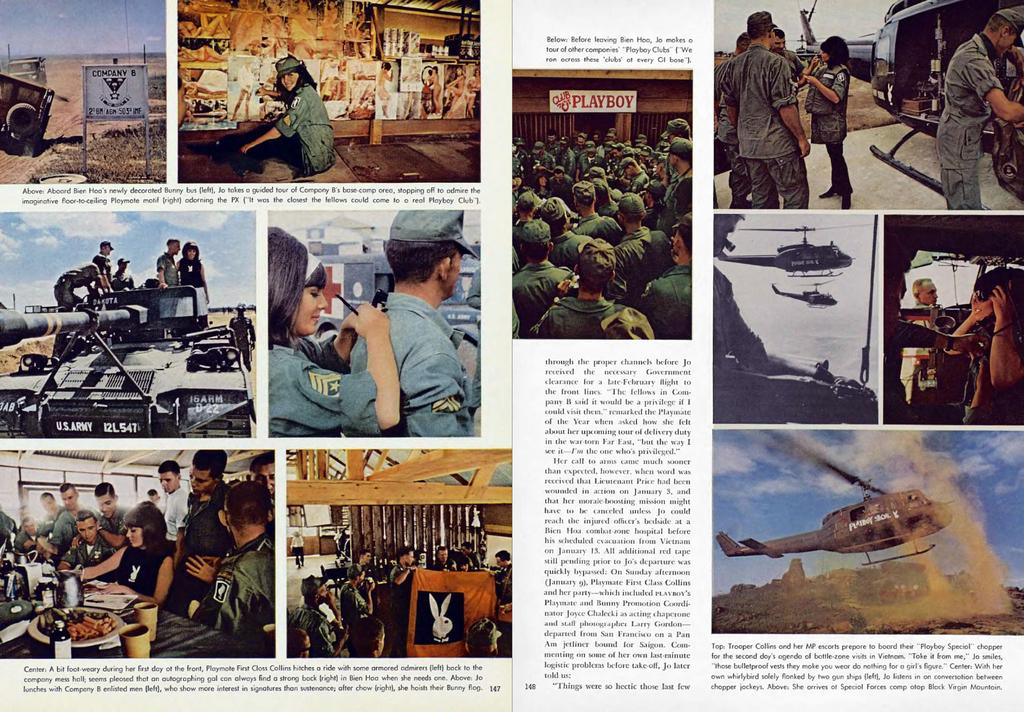<image>
Give a short and clear explanation of the subsequent image. Two pages of a magazine article about Trooper Collins and her troop. 